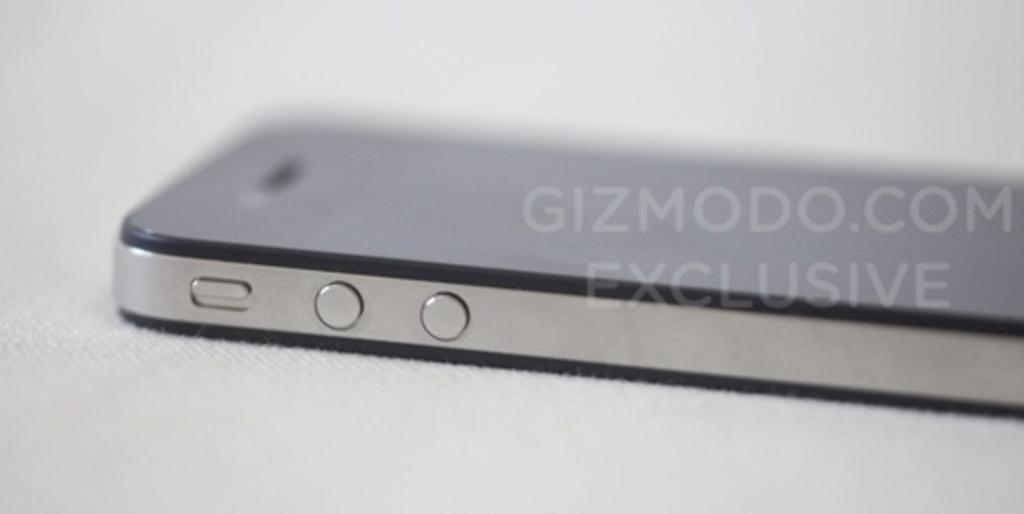<image>
Provide a brief description of the given image. A closeup of a phone has a Gizmodo.com watermark over it. 